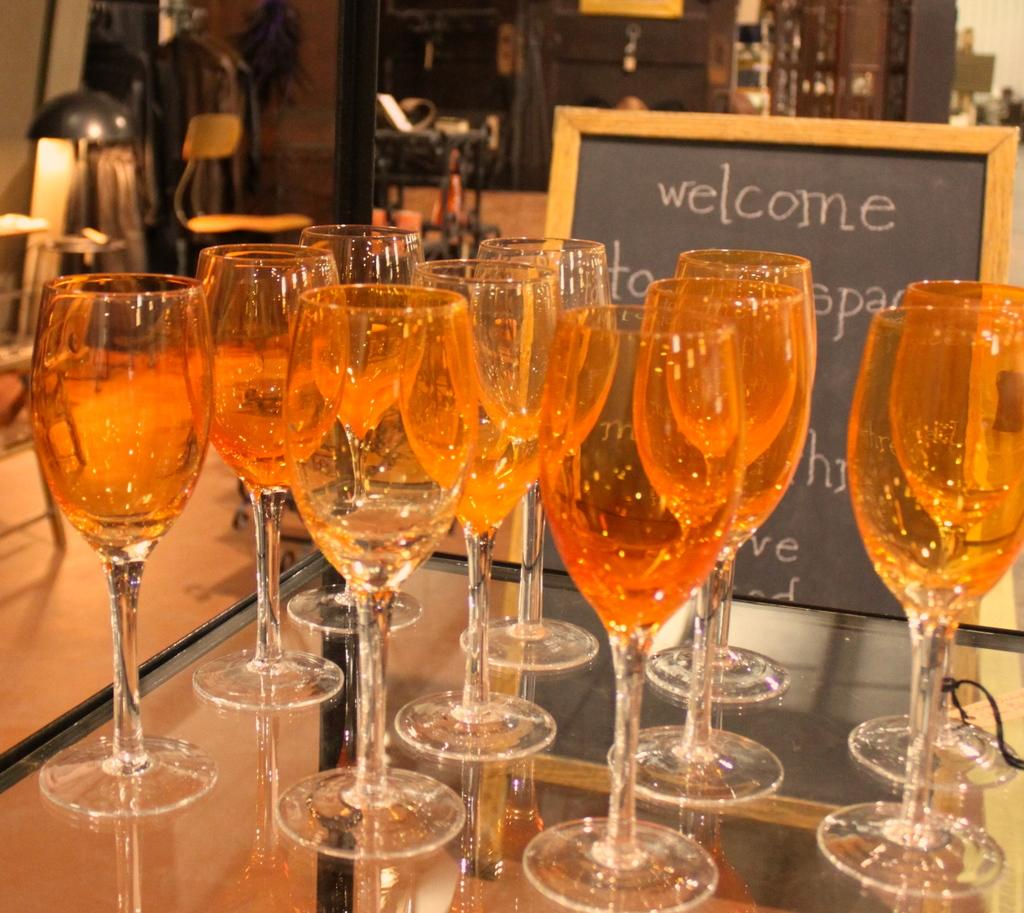What objects are on the table in the image? There are glasses on the table. What is located beside the glasses on the table? There is a board beside the glasses. What can be seen in the background of the image? There are lights and chairs in the background. How many sofas are visible in the image? There are no sofas present in the image. What type of coach can be seen in the background of the image? There is no coach present in the image. 